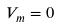<formula> <loc_0><loc_0><loc_500><loc_500>V _ { m } = 0</formula> 